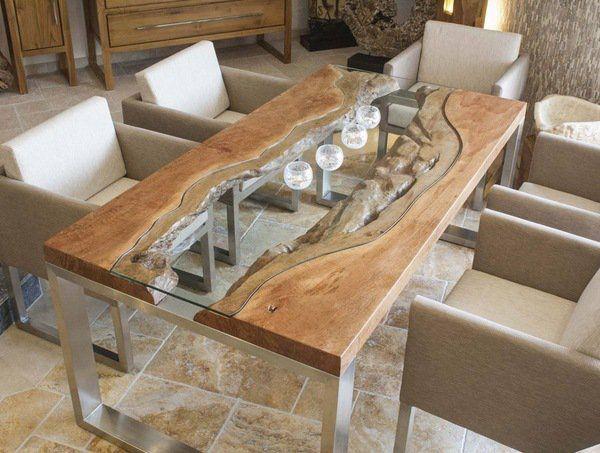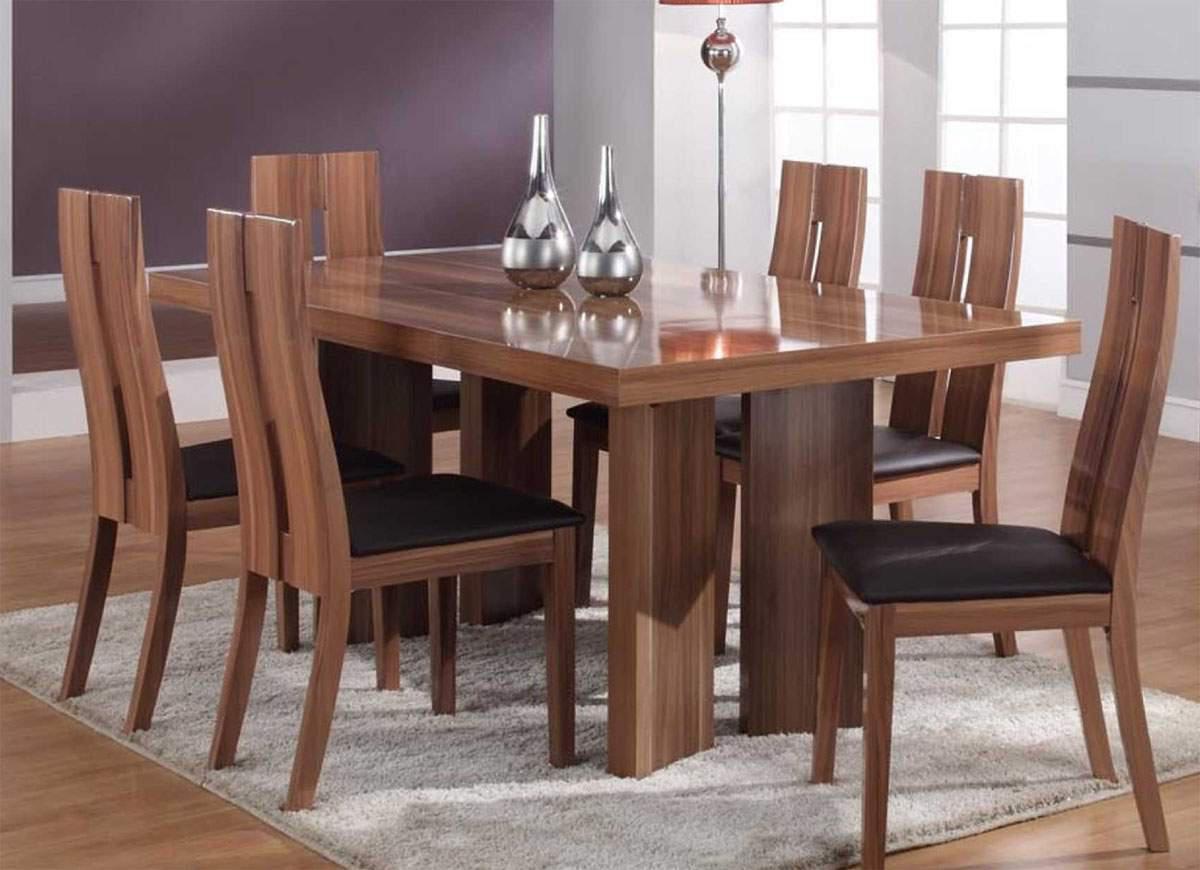The first image is the image on the left, the second image is the image on the right. Examine the images to the left and right. Is the description "In one image, a rectangular table has long bench seating on one side." accurate? Answer yes or no. No. The first image is the image on the left, the second image is the image on the right. Considering the images on both sides, is "There is a vase on the table in the image on the right." valid? Answer yes or no. Yes. 